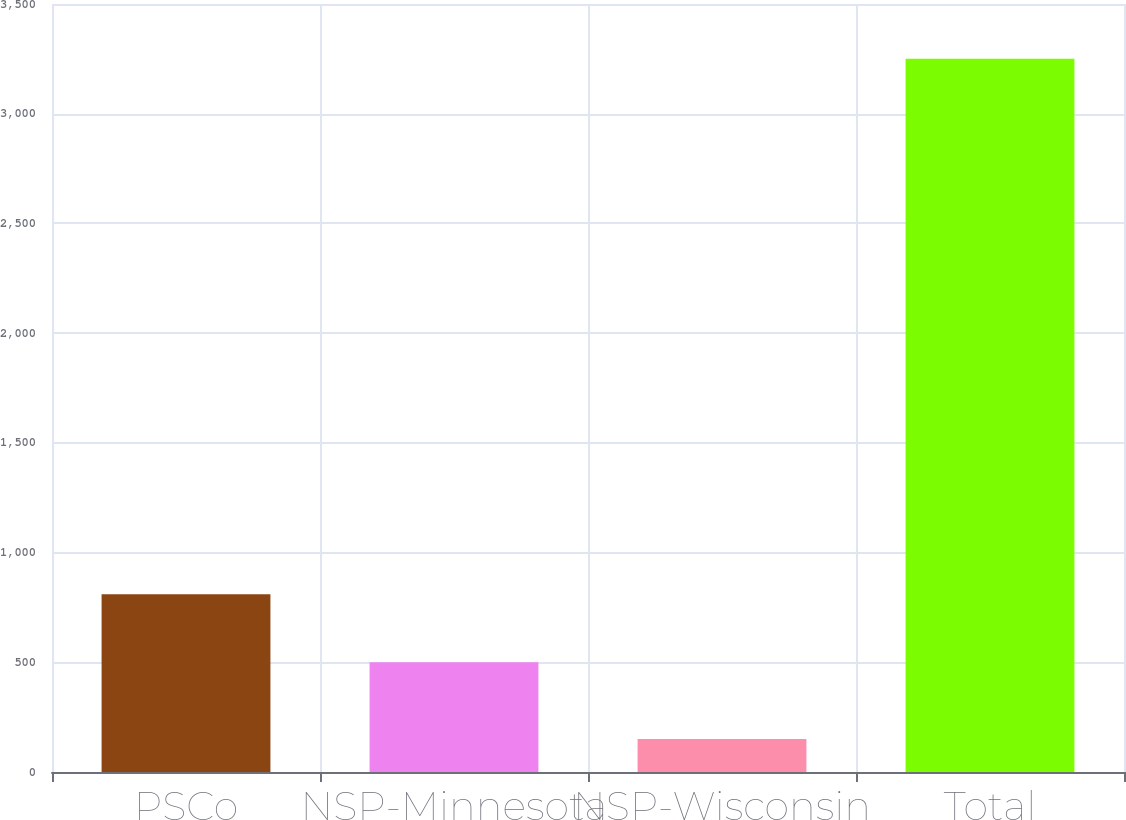<chart> <loc_0><loc_0><loc_500><loc_500><bar_chart><fcel>PSCo<fcel>NSP-Minnesota<fcel>NSP-Wisconsin<fcel>Total<nl><fcel>810<fcel>500<fcel>150<fcel>3250<nl></chart> 